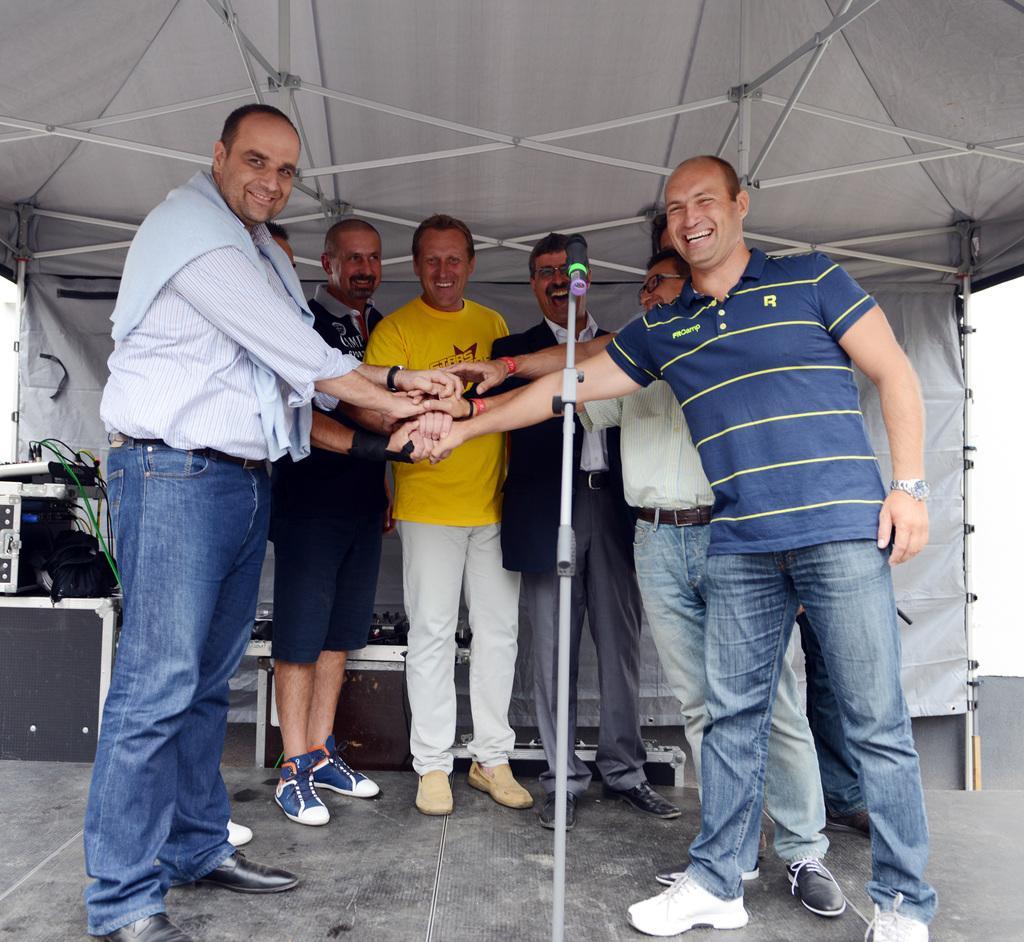Can you describe this image briefly? In this image I can see a group of people are shaking their hands and smiling. In the middle there is a microphone, at the top it looks like a microphone. At the top it looks like a tent. 